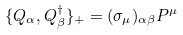Convert formula to latex. <formula><loc_0><loc_0><loc_500><loc_500>\{ Q _ { \alpha } , Q _ { \beta } ^ { \dagger } \} _ { + } = ( \sigma _ { \mu } ) _ { \alpha \beta } P ^ { \mu }</formula> 